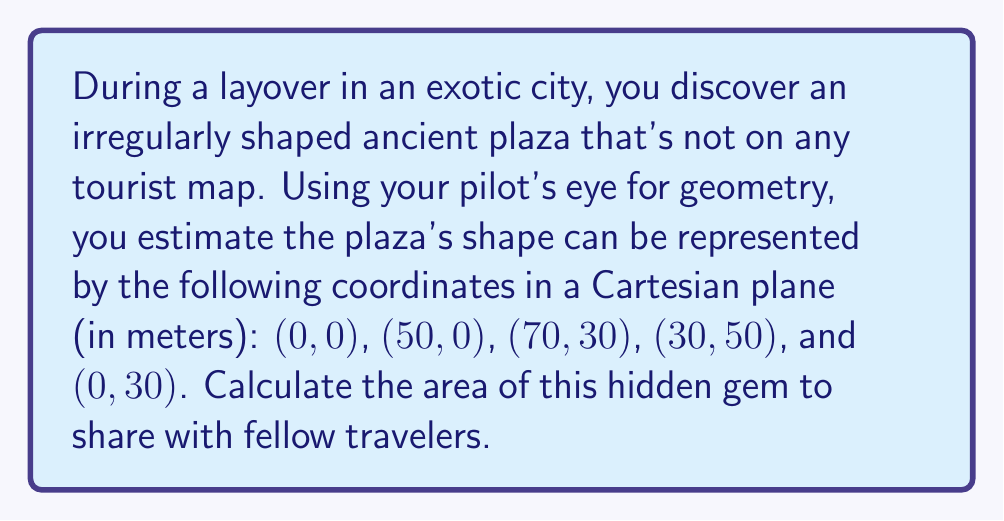Provide a solution to this math problem. To find the area of this irregular shape, we can use the Shoelace formula (also known as the surveyor's formula). This method works for any polygon given its vertices.

Step 1: Arrange the coordinates in order, repeating the first coordinate at the end.
$$(0,0), (50,0), (70,30), (30,50), (0,30), (0,0)$$

Step 2: Apply the Shoelace formula:
$$A = \frac{1}{2}|(x_1y_2 + x_2y_3 + ... + x_ny_1) - (y_1x_2 + y_2x_3 + ... + y_nx_1)|$$

Step 3: Calculate each term:
$$(0 \cdot 0) + (50 \cdot 30) + (70 \cdot 50) + (30 \cdot 30) + (0 \cdot 0) = 1500 + 3500 + 900 = 5900$$
$$(0 \cdot 50) + (0 \cdot 70) + (30 \cdot 30) + (50 \cdot 0) + (30 \cdot 0) = 900$$

Step 4: Subtract and take the absolute value:
$$|5900 - 900| = 5000$$

Step 5: Divide by 2:
$$\frac{5000}{2} = 2500$$

Therefore, the area of the ancient plaza is 2500 square meters.
Answer: 2500 m² 